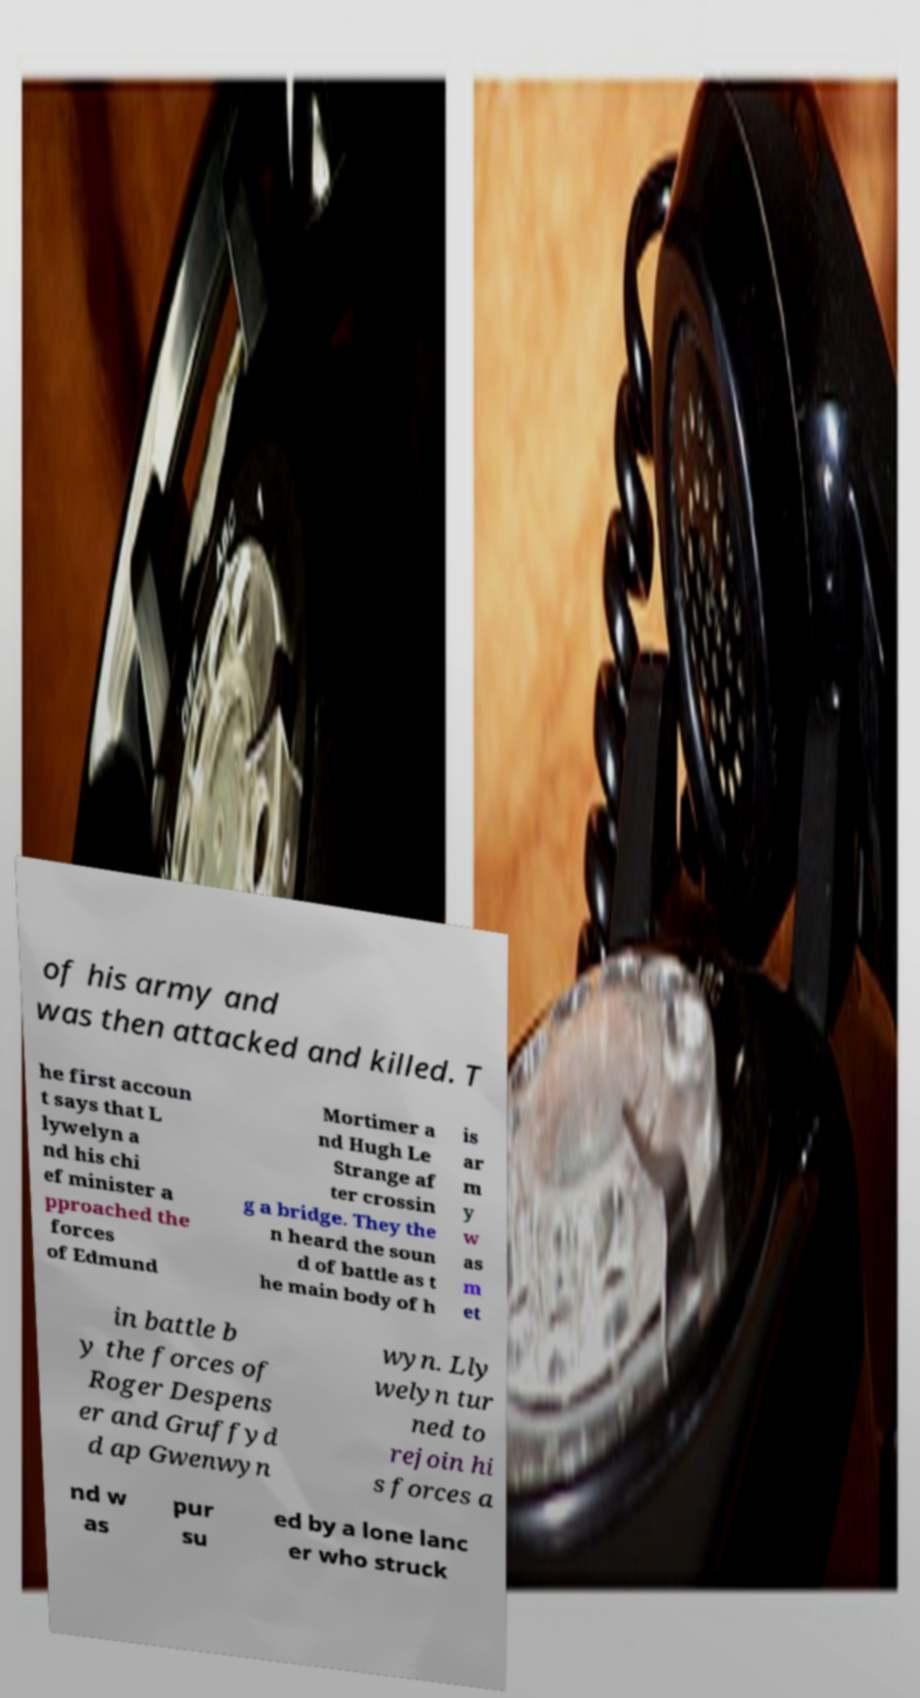What messages or text are displayed in this image? I need them in a readable, typed format. of his army and was then attacked and killed. T he first accoun t says that L lywelyn a nd his chi ef minister a pproached the forces of Edmund Mortimer a nd Hugh Le Strange af ter crossin g a bridge. They the n heard the soun d of battle as t he main body of h is ar m y w as m et in battle b y the forces of Roger Despens er and Gruffyd d ap Gwenwyn wyn. Lly welyn tur ned to rejoin hi s forces a nd w as pur su ed by a lone lanc er who struck 